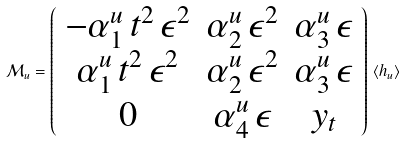Convert formula to latex. <formula><loc_0><loc_0><loc_500><loc_500>\mathcal { M } _ { u } = \left ( \begin{array} { c c c } - \alpha ^ { u } _ { 1 } \, t ^ { 2 } \, \epsilon ^ { 2 } & \alpha ^ { u } _ { 2 } \, \epsilon ^ { 2 } & \alpha ^ { u } _ { 3 } \, \epsilon \\ \alpha ^ { u } _ { 1 } \, t ^ { 2 } \, \epsilon ^ { 2 } & \alpha ^ { u } _ { 2 } \, \epsilon ^ { 2 } & \alpha ^ { u } _ { 3 } \, \epsilon \\ 0 & \alpha ^ { u } _ { 4 } \, \epsilon & y _ { t } \end{array} \right ) \, \langle h _ { u } \rangle</formula> 